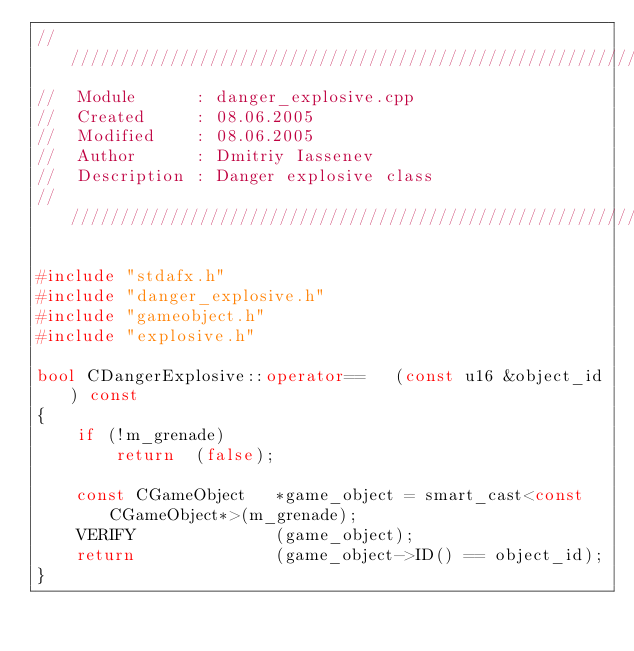Convert code to text. <code><loc_0><loc_0><loc_500><loc_500><_C++_>////////////////////////////////////////////////////////////////////////////
//	Module 		: danger_explosive.cpp
//	Created 	: 08.06.2005
//  Modified 	: 08.06.2005
//	Author		: Dmitriy Iassenev
//	Description : Danger explosive class
////////////////////////////////////////////////////////////////////////////

#include "stdafx.h"
#include "danger_explosive.h"
#include "gameobject.h"
#include "explosive.h"

bool CDangerExplosive::operator==	(const u16 &object_id) const
{
	if (!m_grenade)
		return	(false);
	
	const CGameObject	*game_object = smart_cast<const CGameObject*>(m_grenade);
	VERIFY				(game_object);
	return				(game_object->ID() == object_id);
}
</code> 